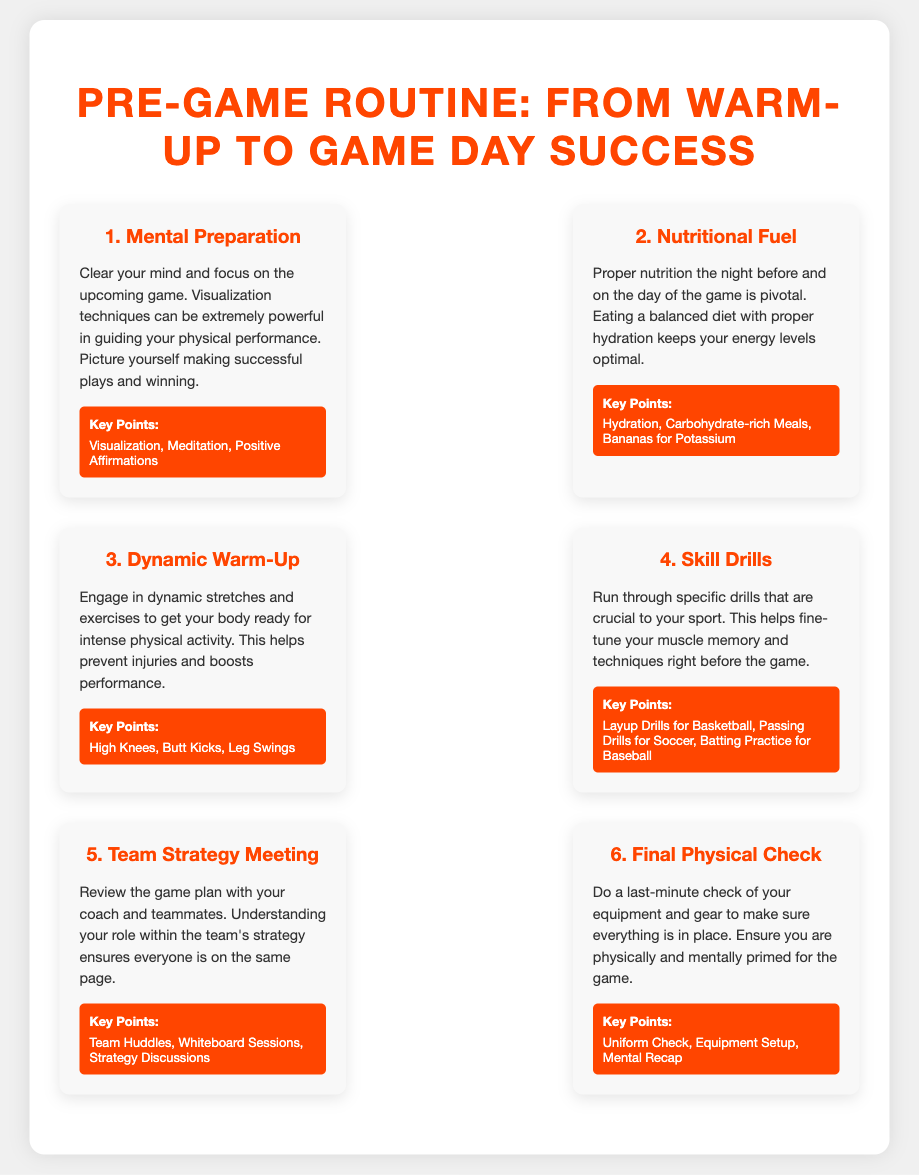What is the first step in the pre-game routine? The first step is about mental preparation, focusing on clearing the mind and visualizing success.
Answer: Mental Preparation What should you eat the night before the game? The document states that proper nutrition includes eating a balanced diet and staying hydrated.
Answer: Balanced diet What is an example of a dynamic warm-up exercise? The infographic mentions high knees, butt kicks, and leg swings as examples of dynamic warm-up exercises.
Answer: High Knees What is the purpose of the skill drills? Skill drills help to fine-tune muscle memory and techniques right before the game, ensuring preparation.
Answer: Fine-tune muscle memory What is emphasized during the team strategy meeting? It is important to review the game plan and understand each player's role within the team's strategy.
Answer: Game plan review What should be checked during the final physical check? The final check includes ensuring the equipment and gear are in place and that one is mentally prepared.
Answer: Equipment setup How many steps are outlined in the pre-game routine? The infographic lists six distinct steps in the pre-game routine process.
Answer: Six steps What key point is associated with nutritional fuel? Staying hydrated is a crucial aspect of nutritional fuel as mentioned in the document.
Answer: Hydration 